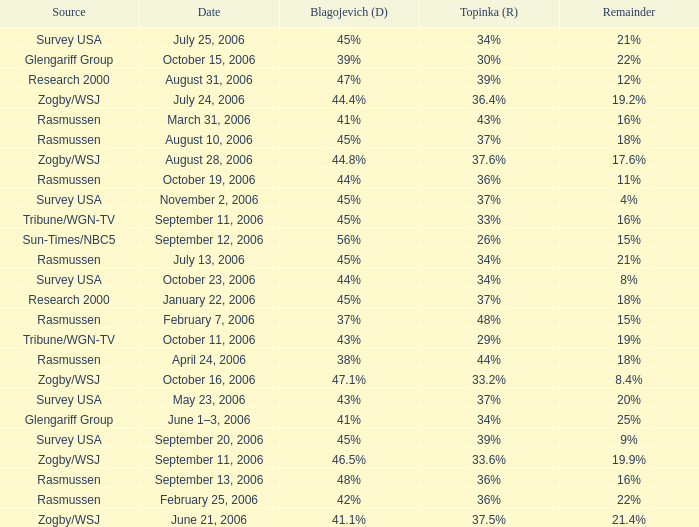Which Blagojevich (D) happened on october 16, 2006? 47.1%. 